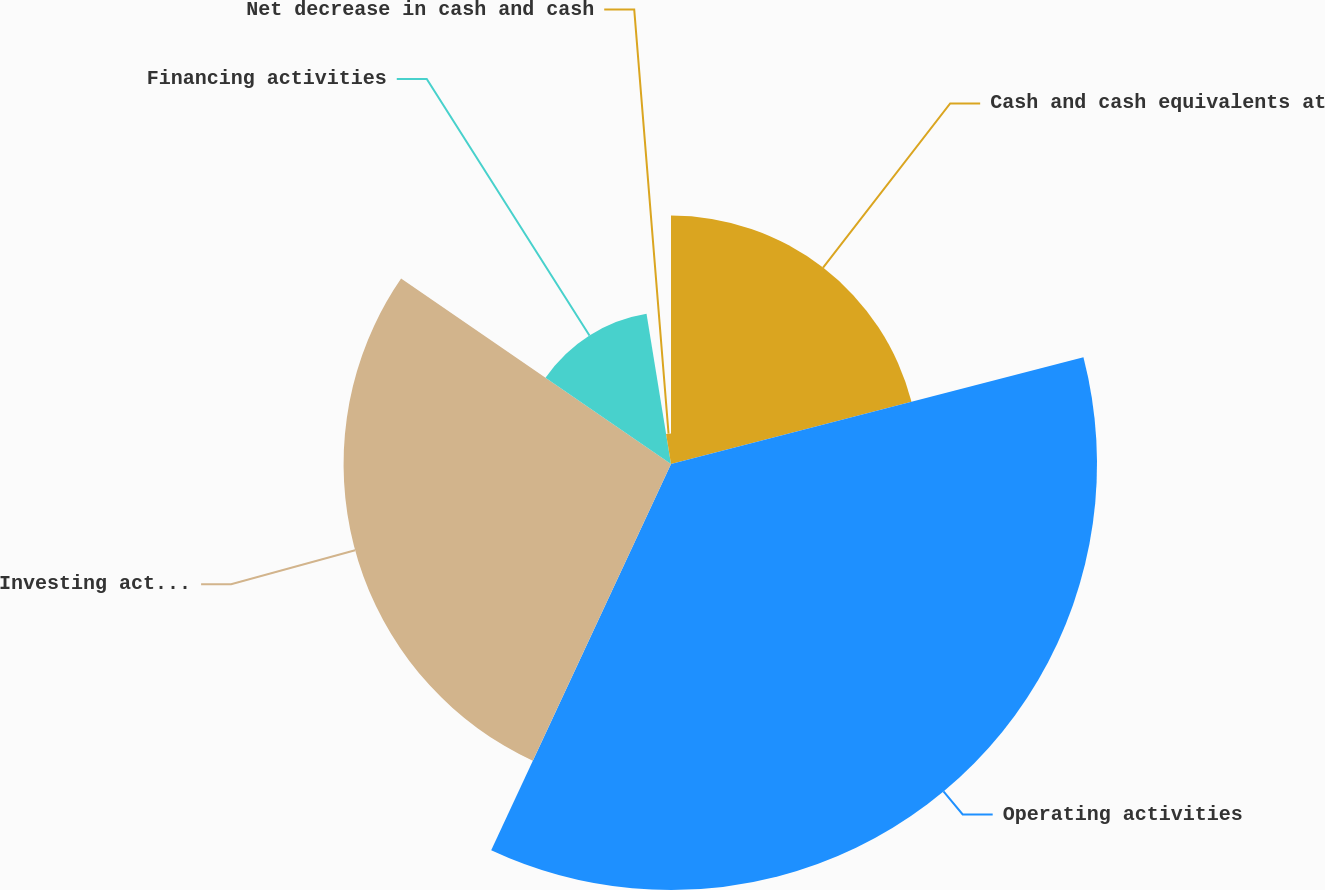Convert chart to OTSL. <chart><loc_0><loc_0><loc_500><loc_500><pie_chart><fcel>Cash and cash equivalents at<fcel>Operating activities<fcel>Investing activities<fcel>Financing activities<fcel>Net decrease in cash and cash<nl><fcel>20.97%<fcel>35.96%<fcel>27.64%<fcel>12.85%<fcel>2.57%<nl></chart> 